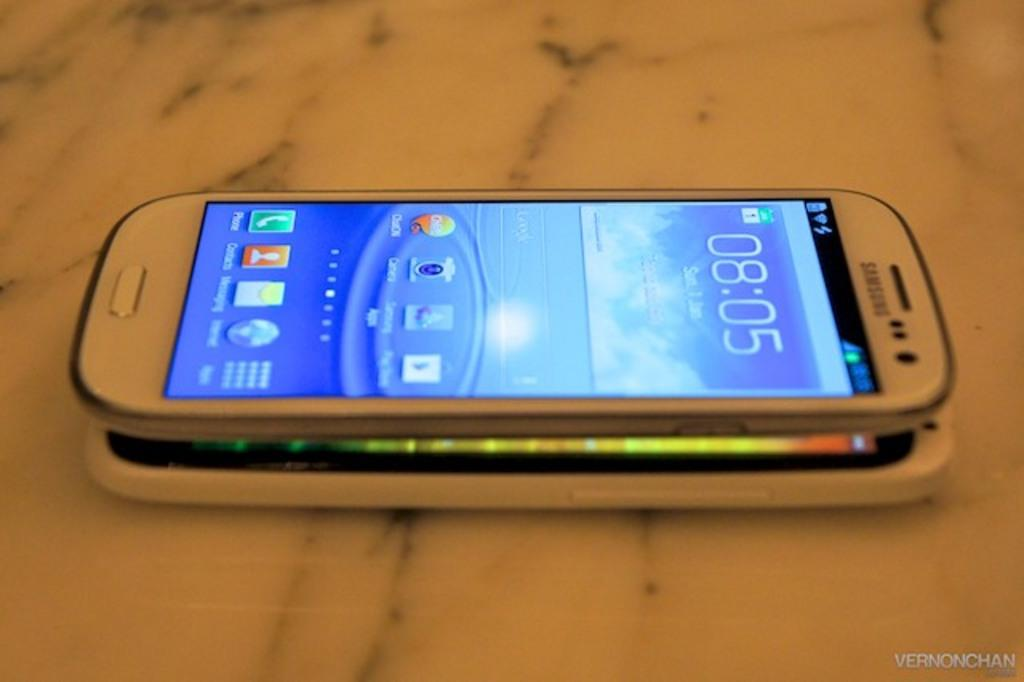<image>
Give a short and clear explanation of the subsequent image. A white Samsung phone is on top of another phone. 